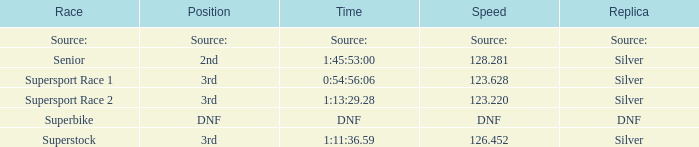Which race has a replica of DNF? Superbike. 